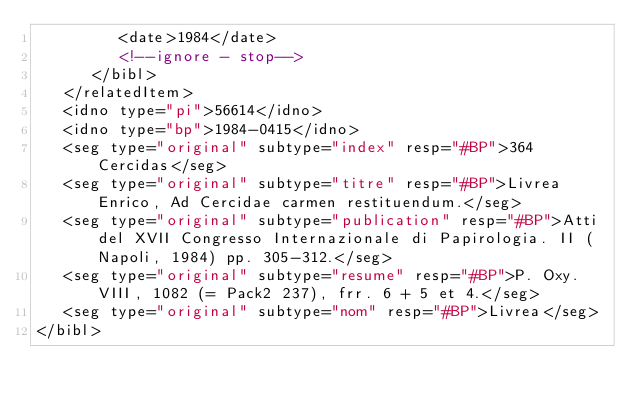<code> <loc_0><loc_0><loc_500><loc_500><_XML_>         <date>1984</date>
         <!--ignore - stop-->
      </bibl>
   </relatedItem>
   <idno type="pi">56614</idno>
   <idno type="bp">1984-0415</idno>
   <seg type="original" subtype="index" resp="#BP">364 Cercidas</seg>
   <seg type="original" subtype="titre" resp="#BP">Livrea Enrico, Ad Cercidae carmen restituendum.</seg>
   <seg type="original" subtype="publication" resp="#BP">Atti del XVII Congresso Internazionale di Papirologia. II (Napoli, 1984) pp. 305-312.</seg>
   <seg type="original" subtype="resume" resp="#BP">P. Oxy. VIII, 1082 (= Pack2 237), frr. 6 + 5 et 4.</seg>
   <seg type="original" subtype="nom" resp="#BP">Livrea</seg>
</bibl>
</code> 